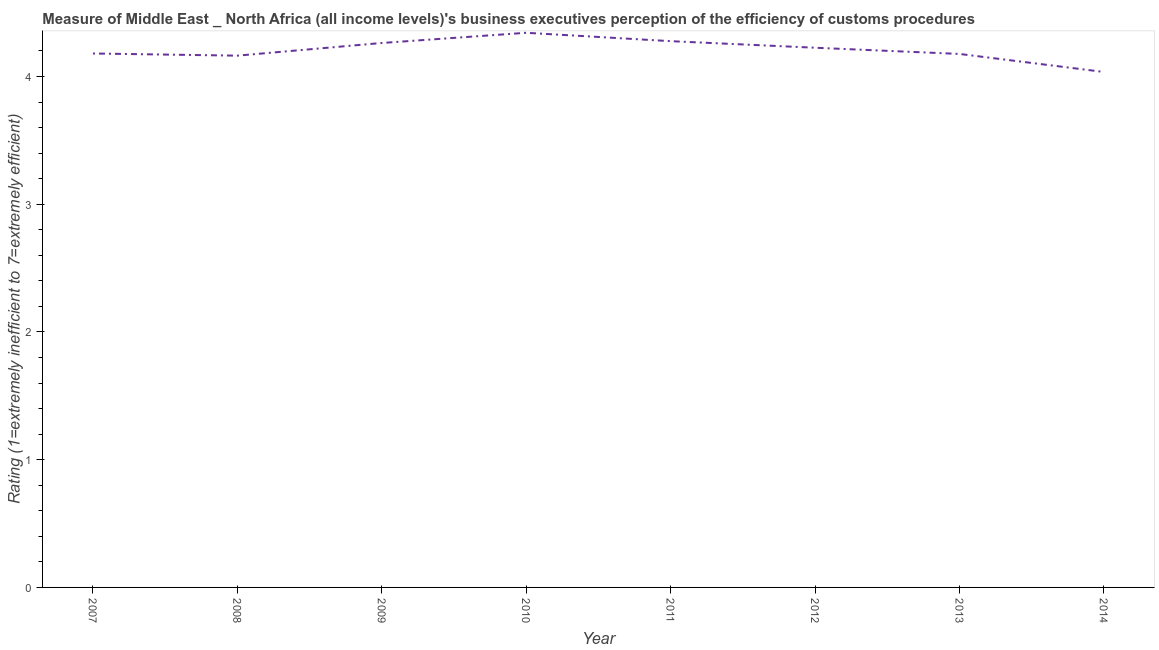What is the rating measuring burden of customs procedure in 2012?
Offer a very short reply. 4.22. Across all years, what is the maximum rating measuring burden of customs procedure?
Offer a very short reply. 4.34. Across all years, what is the minimum rating measuring burden of customs procedure?
Provide a short and direct response. 4.04. In which year was the rating measuring burden of customs procedure maximum?
Provide a short and direct response. 2010. In which year was the rating measuring burden of customs procedure minimum?
Ensure brevity in your answer.  2014. What is the sum of the rating measuring burden of customs procedure?
Your answer should be very brief. 33.66. What is the difference between the rating measuring burden of customs procedure in 2010 and 2013?
Give a very brief answer. 0.17. What is the average rating measuring burden of customs procedure per year?
Keep it short and to the point. 4.21. What is the median rating measuring burden of customs procedure?
Make the answer very short. 4.2. In how many years, is the rating measuring burden of customs procedure greater than 2 ?
Your answer should be compact. 8. What is the ratio of the rating measuring burden of customs procedure in 2008 to that in 2009?
Give a very brief answer. 0.98. Is the rating measuring burden of customs procedure in 2007 less than that in 2010?
Provide a succinct answer. Yes. Is the difference between the rating measuring burden of customs procedure in 2010 and 2012 greater than the difference between any two years?
Give a very brief answer. No. What is the difference between the highest and the second highest rating measuring burden of customs procedure?
Make the answer very short. 0.07. What is the difference between the highest and the lowest rating measuring burden of customs procedure?
Offer a very short reply. 0.31. In how many years, is the rating measuring burden of customs procedure greater than the average rating measuring burden of customs procedure taken over all years?
Keep it short and to the point. 4. How many years are there in the graph?
Your answer should be very brief. 8. Does the graph contain any zero values?
Make the answer very short. No. Does the graph contain grids?
Offer a very short reply. No. What is the title of the graph?
Your answer should be compact. Measure of Middle East _ North Africa (all income levels)'s business executives perception of the efficiency of customs procedures. What is the label or title of the X-axis?
Ensure brevity in your answer.  Year. What is the label or title of the Y-axis?
Your response must be concise. Rating (1=extremely inefficient to 7=extremely efficient). What is the Rating (1=extremely inefficient to 7=extremely efficient) of 2007?
Make the answer very short. 4.18. What is the Rating (1=extremely inefficient to 7=extremely efficient) of 2008?
Your response must be concise. 4.16. What is the Rating (1=extremely inefficient to 7=extremely efficient) in 2009?
Offer a very short reply. 4.26. What is the Rating (1=extremely inefficient to 7=extremely efficient) in 2010?
Your response must be concise. 4.34. What is the Rating (1=extremely inefficient to 7=extremely efficient) of 2011?
Keep it short and to the point. 4.28. What is the Rating (1=extremely inefficient to 7=extremely efficient) in 2012?
Provide a succinct answer. 4.22. What is the Rating (1=extremely inefficient to 7=extremely efficient) of 2013?
Give a very brief answer. 4.18. What is the Rating (1=extremely inefficient to 7=extremely efficient) of 2014?
Provide a short and direct response. 4.04. What is the difference between the Rating (1=extremely inefficient to 7=extremely efficient) in 2007 and 2008?
Ensure brevity in your answer.  0.02. What is the difference between the Rating (1=extremely inefficient to 7=extremely efficient) in 2007 and 2009?
Your answer should be very brief. -0.08. What is the difference between the Rating (1=extremely inefficient to 7=extremely efficient) in 2007 and 2010?
Make the answer very short. -0.16. What is the difference between the Rating (1=extremely inefficient to 7=extremely efficient) in 2007 and 2011?
Your answer should be very brief. -0.1. What is the difference between the Rating (1=extremely inefficient to 7=extremely efficient) in 2007 and 2012?
Keep it short and to the point. -0.04. What is the difference between the Rating (1=extremely inefficient to 7=extremely efficient) in 2007 and 2013?
Provide a short and direct response. 0. What is the difference between the Rating (1=extremely inefficient to 7=extremely efficient) in 2007 and 2014?
Your answer should be very brief. 0.14. What is the difference between the Rating (1=extremely inefficient to 7=extremely efficient) in 2008 and 2009?
Ensure brevity in your answer.  -0.1. What is the difference between the Rating (1=extremely inefficient to 7=extremely efficient) in 2008 and 2010?
Give a very brief answer. -0.18. What is the difference between the Rating (1=extremely inefficient to 7=extremely efficient) in 2008 and 2011?
Provide a succinct answer. -0.11. What is the difference between the Rating (1=extremely inefficient to 7=extremely efficient) in 2008 and 2012?
Your response must be concise. -0.06. What is the difference between the Rating (1=extremely inefficient to 7=extremely efficient) in 2008 and 2013?
Make the answer very short. -0.01. What is the difference between the Rating (1=extremely inefficient to 7=extremely efficient) in 2008 and 2014?
Ensure brevity in your answer.  0.13. What is the difference between the Rating (1=extremely inefficient to 7=extremely efficient) in 2009 and 2010?
Provide a succinct answer. -0.08. What is the difference between the Rating (1=extremely inefficient to 7=extremely efficient) in 2009 and 2011?
Make the answer very short. -0.01. What is the difference between the Rating (1=extremely inefficient to 7=extremely efficient) in 2009 and 2012?
Keep it short and to the point. 0.04. What is the difference between the Rating (1=extremely inefficient to 7=extremely efficient) in 2009 and 2013?
Ensure brevity in your answer.  0.09. What is the difference between the Rating (1=extremely inefficient to 7=extremely efficient) in 2009 and 2014?
Give a very brief answer. 0.23. What is the difference between the Rating (1=extremely inefficient to 7=extremely efficient) in 2010 and 2011?
Your response must be concise. 0.07. What is the difference between the Rating (1=extremely inefficient to 7=extremely efficient) in 2010 and 2012?
Make the answer very short. 0.12. What is the difference between the Rating (1=extremely inefficient to 7=extremely efficient) in 2010 and 2013?
Keep it short and to the point. 0.17. What is the difference between the Rating (1=extremely inefficient to 7=extremely efficient) in 2010 and 2014?
Your answer should be compact. 0.31. What is the difference between the Rating (1=extremely inefficient to 7=extremely efficient) in 2011 and 2012?
Keep it short and to the point. 0.05. What is the difference between the Rating (1=extremely inefficient to 7=extremely efficient) in 2011 and 2014?
Make the answer very short. 0.24. What is the difference between the Rating (1=extremely inefficient to 7=extremely efficient) in 2012 and 2013?
Your answer should be compact. 0.05. What is the difference between the Rating (1=extremely inefficient to 7=extremely efficient) in 2012 and 2014?
Offer a terse response. 0.19. What is the difference between the Rating (1=extremely inefficient to 7=extremely efficient) in 2013 and 2014?
Your response must be concise. 0.14. What is the ratio of the Rating (1=extremely inefficient to 7=extremely efficient) in 2007 to that in 2008?
Keep it short and to the point. 1. What is the ratio of the Rating (1=extremely inefficient to 7=extremely efficient) in 2007 to that in 2009?
Give a very brief answer. 0.98. What is the ratio of the Rating (1=extremely inefficient to 7=extremely efficient) in 2007 to that in 2011?
Provide a short and direct response. 0.98. What is the ratio of the Rating (1=extremely inefficient to 7=extremely efficient) in 2007 to that in 2013?
Your response must be concise. 1. What is the ratio of the Rating (1=extremely inefficient to 7=extremely efficient) in 2007 to that in 2014?
Your response must be concise. 1.04. What is the ratio of the Rating (1=extremely inefficient to 7=extremely efficient) in 2008 to that in 2009?
Provide a succinct answer. 0.98. What is the ratio of the Rating (1=extremely inefficient to 7=extremely efficient) in 2008 to that in 2012?
Make the answer very short. 0.98. What is the ratio of the Rating (1=extremely inefficient to 7=extremely efficient) in 2008 to that in 2014?
Make the answer very short. 1.03. What is the ratio of the Rating (1=extremely inefficient to 7=extremely efficient) in 2009 to that in 2012?
Provide a short and direct response. 1.01. What is the ratio of the Rating (1=extremely inefficient to 7=extremely efficient) in 2009 to that in 2014?
Make the answer very short. 1.06. What is the ratio of the Rating (1=extremely inefficient to 7=extremely efficient) in 2010 to that in 2011?
Provide a short and direct response. 1.01. What is the ratio of the Rating (1=extremely inefficient to 7=extremely efficient) in 2010 to that in 2012?
Your answer should be very brief. 1.03. What is the ratio of the Rating (1=extremely inefficient to 7=extremely efficient) in 2010 to that in 2014?
Provide a short and direct response. 1.08. What is the ratio of the Rating (1=extremely inefficient to 7=extremely efficient) in 2011 to that in 2012?
Your answer should be very brief. 1.01. What is the ratio of the Rating (1=extremely inefficient to 7=extremely efficient) in 2011 to that in 2013?
Your response must be concise. 1.02. What is the ratio of the Rating (1=extremely inefficient to 7=extremely efficient) in 2011 to that in 2014?
Your answer should be compact. 1.06. What is the ratio of the Rating (1=extremely inefficient to 7=extremely efficient) in 2012 to that in 2014?
Offer a very short reply. 1.05. What is the ratio of the Rating (1=extremely inefficient to 7=extremely efficient) in 2013 to that in 2014?
Your answer should be compact. 1.03. 